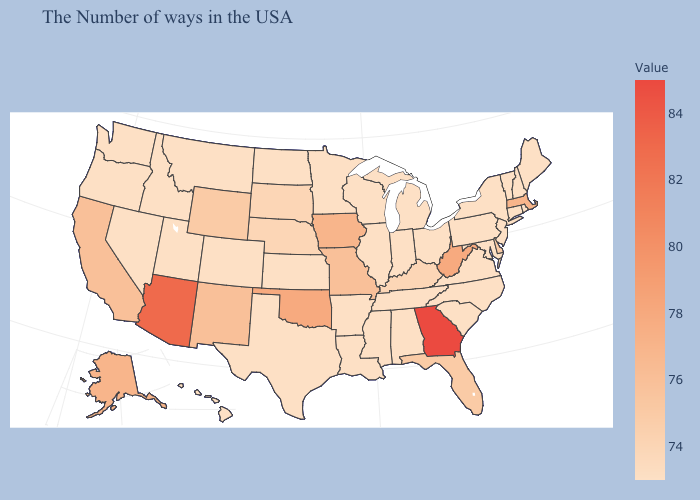Does Illinois have a higher value than New Mexico?
Keep it brief. No. Which states have the lowest value in the Northeast?
Keep it brief. Maine, Rhode Island, New Hampshire, Vermont, Connecticut, New York, New Jersey, Pennsylvania. Does Georgia have the highest value in the USA?
Write a very short answer. Yes. Does Nevada have the lowest value in the West?
Give a very brief answer. Yes. 